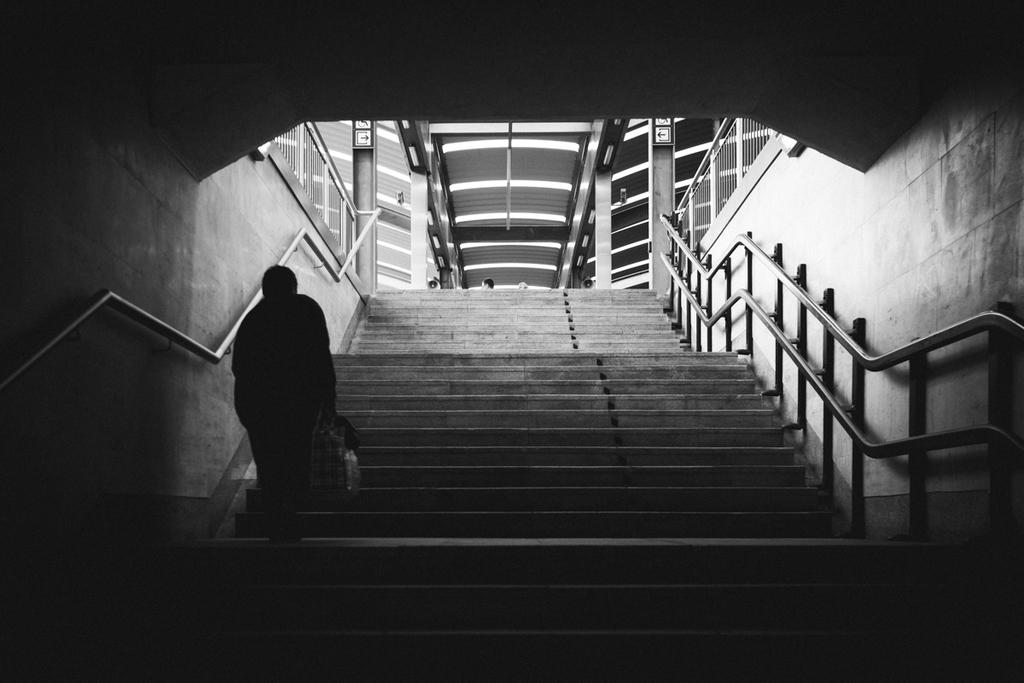What is the color scheme of the image? The image is black and white. What can be seen in the middle of the image? There are stairs in the middle of the image. Is there a person visible in the image? Yes, there is a person on the left side of the image. What type of tomatoes can be seen growing on the stairs in the image? There are no tomatoes present in the image, and the stairs are not a growing environment for plants. 